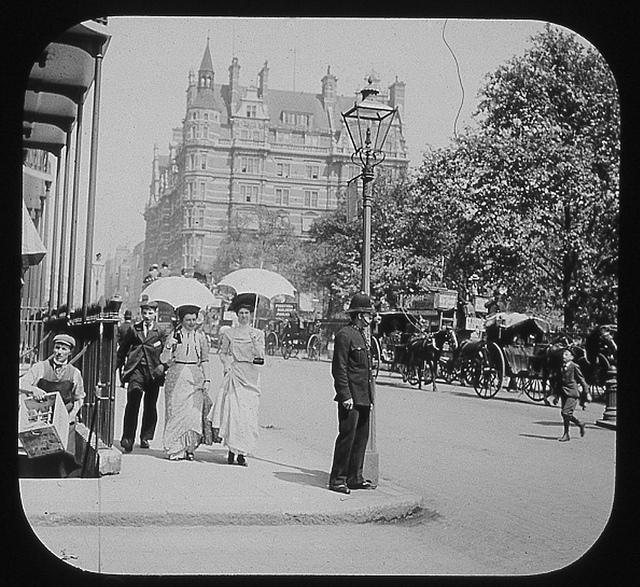What are the women on the left holding?

Choices:
A) babies
B) eggs
C) cats
D) umbrellas umbrellas 